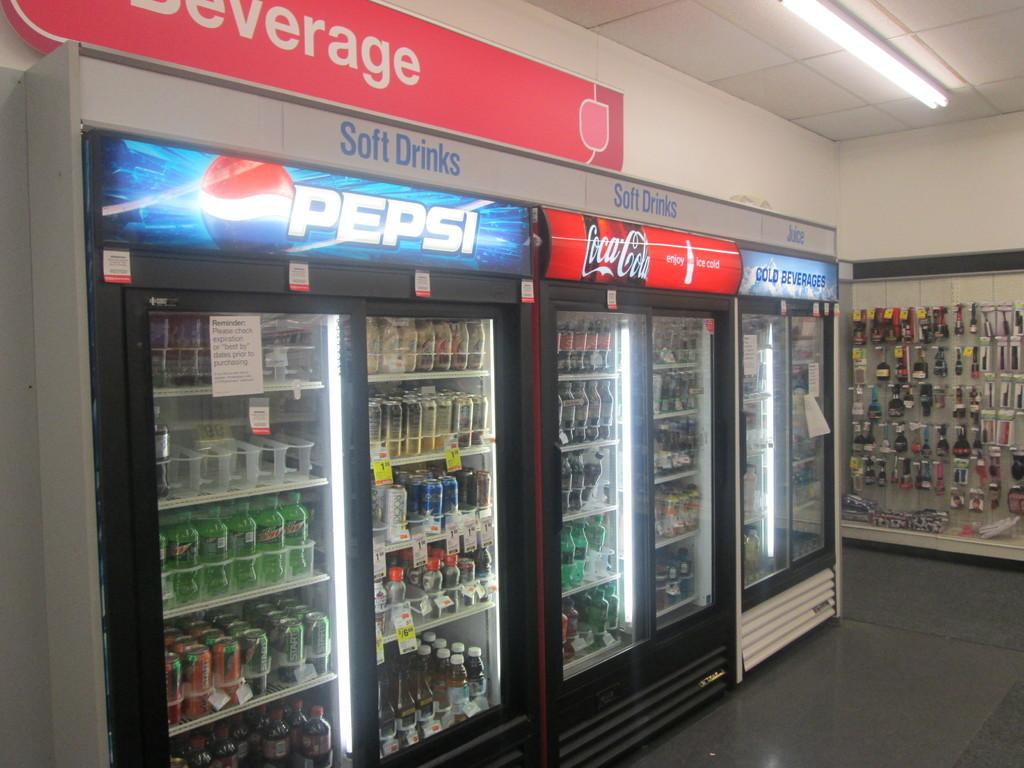<image>
Summarize the visual content of the image. Drink cases holding Pepsi and Coca-Cola products say soft drinks above them. 